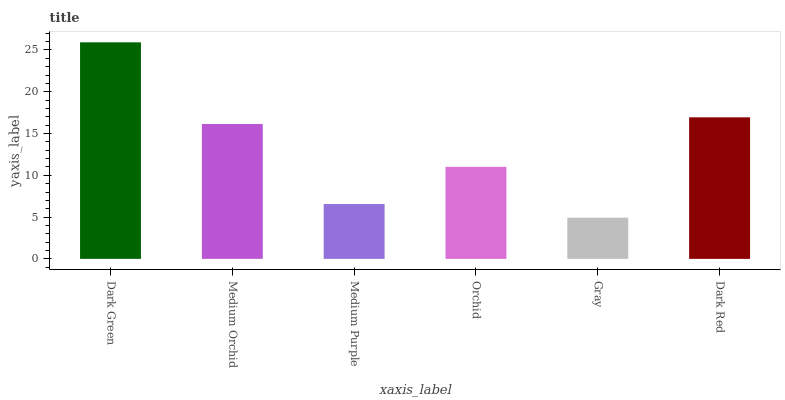Is Gray the minimum?
Answer yes or no. Yes. Is Dark Green the maximum?
Answer yes or no. Yes. Is Medium Orchid the minimum?
Answer yes or no. No. Is Medium Orchid the maximum?
Answer yes or no. No. Is Dark Green greater than Medium Orchid?
Answer yes or no. Yes. Is Medium Orchid less than Dark Green?
Answer yes or no. Yes. Is Medium Orchid greater than Dark Green?
Answer yes or no. No. Is Dark Green less than Medium Orchid?
Answer yes or no. No. Is Medium Orchid the high median?
Answer yes or no. Yes. Is Orchid the low median?
Answer yes or no. Yes. Is Medium Purple the high median?
Answer yes or no. No. Is Gray the low median?
Answer yes or no. No. 